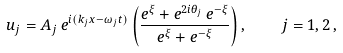<formula> <loc_0><loc_0><loc_500><loc_500>u _ { j } = A _ { j } \, e ^ { i ( k _ { j } x - \omega _ { j } t ) } \left ( \frac { e ^ { \xi } + e ^ { 2 i \theta _ { j } } \, e ^ { - \xi } } { e ^ { \xi } + e ^ { - \xi } } \right ) , \quad j = 1 , 2 \, ,</formula> 